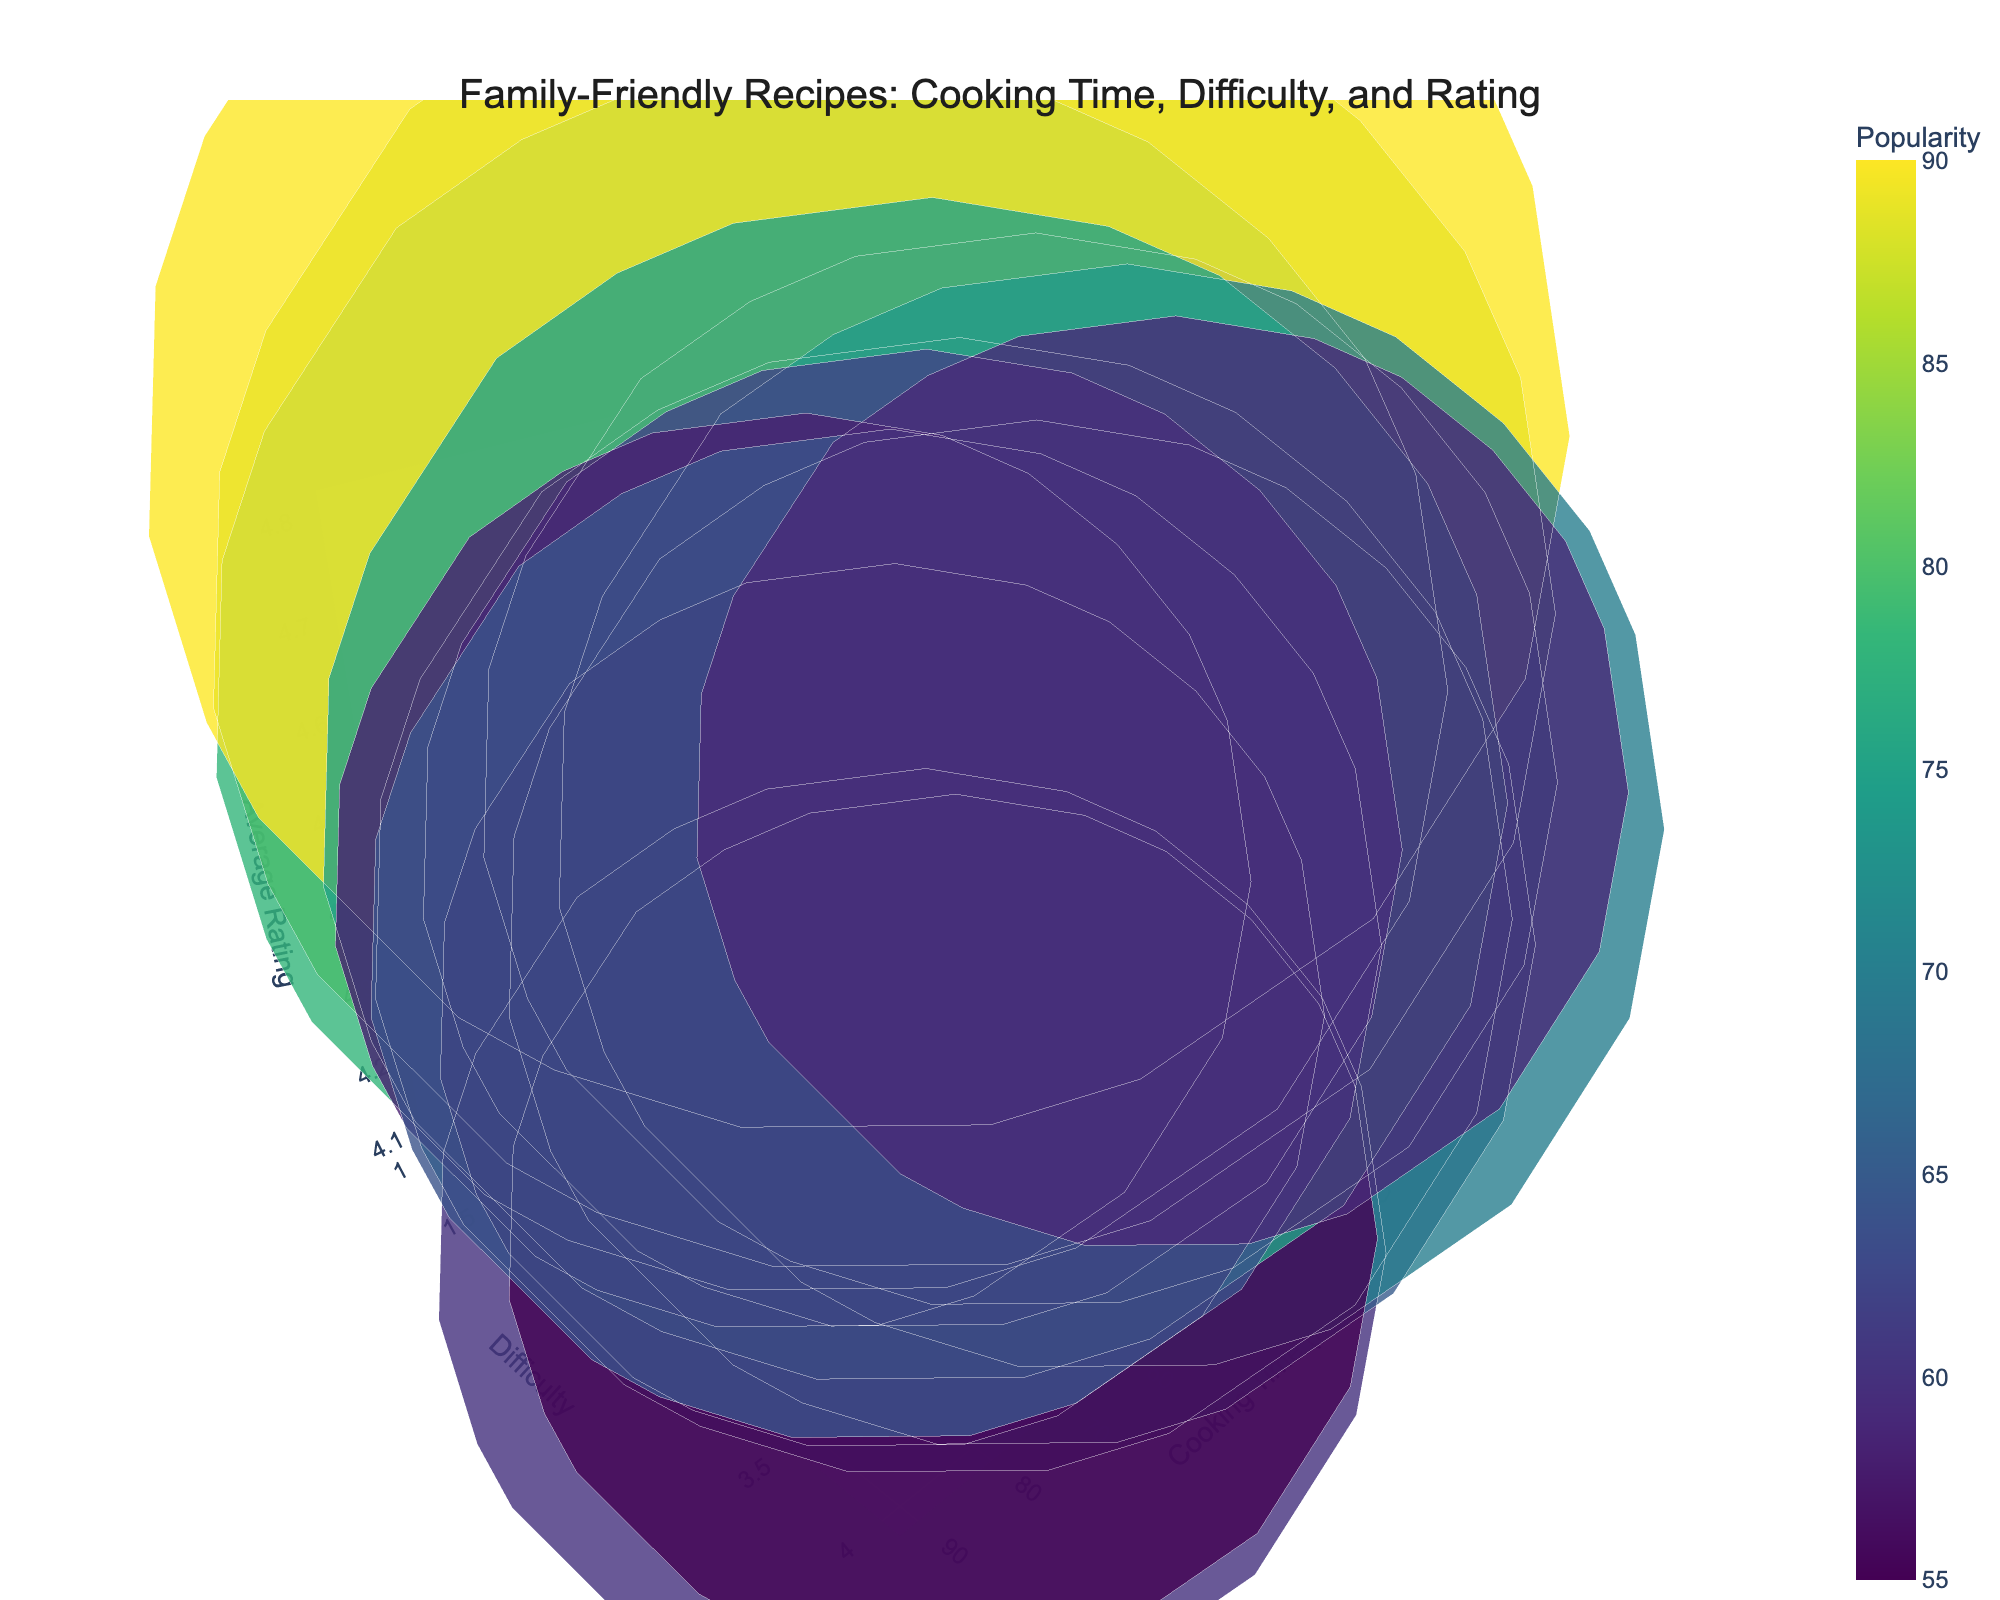How many cuisines are represented in the chart? The chart data shows 15 different cuisines, each associated with a specific recipe.
Answer: 15 What is the title of the chart? The title of the chart can be found at the top of the visualization. It is 'Family-Friendly Recipes: Cooking Time, Difficulty, and Rating'.
Answer: 'Family-Friendly Recipes: Cooking Time, Difficulty, and Rating' Which recipe has the highest average rating? The recipe with the highest average rating has a rating of 4.8, which corresponds to Mac and Cheese.
Answer: Mac and Cheese Which cuisine has the most popular recipe, and what is its popularity score? By observing the size of the bubbles, the largest bubble indicates the most popular recipe. Mac and Cheese from American cuisine is the most popular with a score of 90.
Answer: American (Mac and Cheese), 90 Which recipe has the longest cooking time, and how long does it take? The recipe with the longest cooking time is identified on the Cooking Time axis, which is Pho Ga with an 80-minute cooking time.
Answer: Pho Ga, 80 mins Which two recipes have the same difficulty level but different popularity scores, and what are their differences in popularity? By comparing recipes with the same difficulty level of 2, Spaghetti and Meatballs (85) and Sweet and Sour Chicken (72) show a difference. The difference in popularity is 13.
Answer: Spaghetti and Meatballs and Sweet and Sour Chicken, 13 What's the average cooking time of the recipes with a difficulty level of 3? The recipes with a difficulty level of 3 are Butter Chicken, Pad Thai, Ratatouille, Pho Ga, and Shepherd's Pie. The average cooking time is calculated by summing (50 + 35 + 60 + 80 + 70) and dividing by 5, resulting in 59 minutes.
Answer: 59 mins Which recipes are easier to make and have a cooking time under 30 minutes? The recipes with a difficulty level of 1 and cooking time under 30 mins are Easy Chicken Fajitas (30 mins) and Mac and Cheese (25 mins).
Answer: Easy Chicken Fajitas, Mac and Cheese Identify the recipes with the lowest average ratings and their corresponding cooking times. The recipes with the lowest average rating, which is 4.1, are Ratatouille and their cooking time is 60 mins.
Answer: Ratatouille, 60 mins 